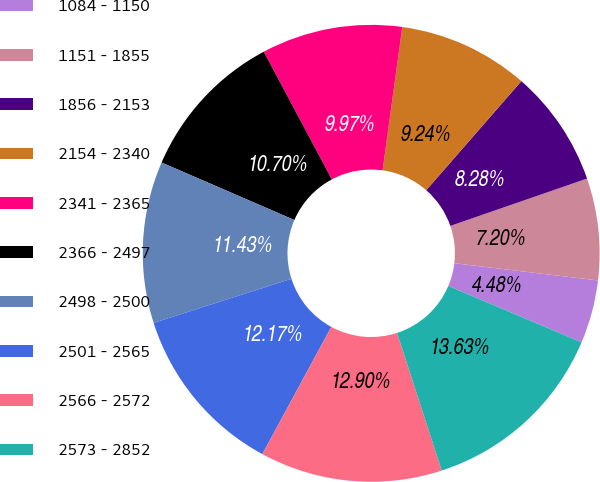Convert chart to OTSL. <chart><loc_0><loc_0><loc_500><loc_500><pie_chart><fcel>1084 - 1150<fcel>1151 - 1855<fcel>1856 - 2153<fcel>2154 - 2340<fcel>2341 - 2365<fcel>2366 - 2497<fcel>2498 - 2500<fcel>2501 - 2565<fcel>2566 - 2572<fcel>2573 - 2852<nl><fcel>4.48%<fcel>7.2%<fcel>8.28%<fcel>9.24%<fcel>9.97%<fcel>10.7%<fcel>11.43%<fcel>12.17%<fcel>12.9%<fcel>13.63%<nl></chart> 